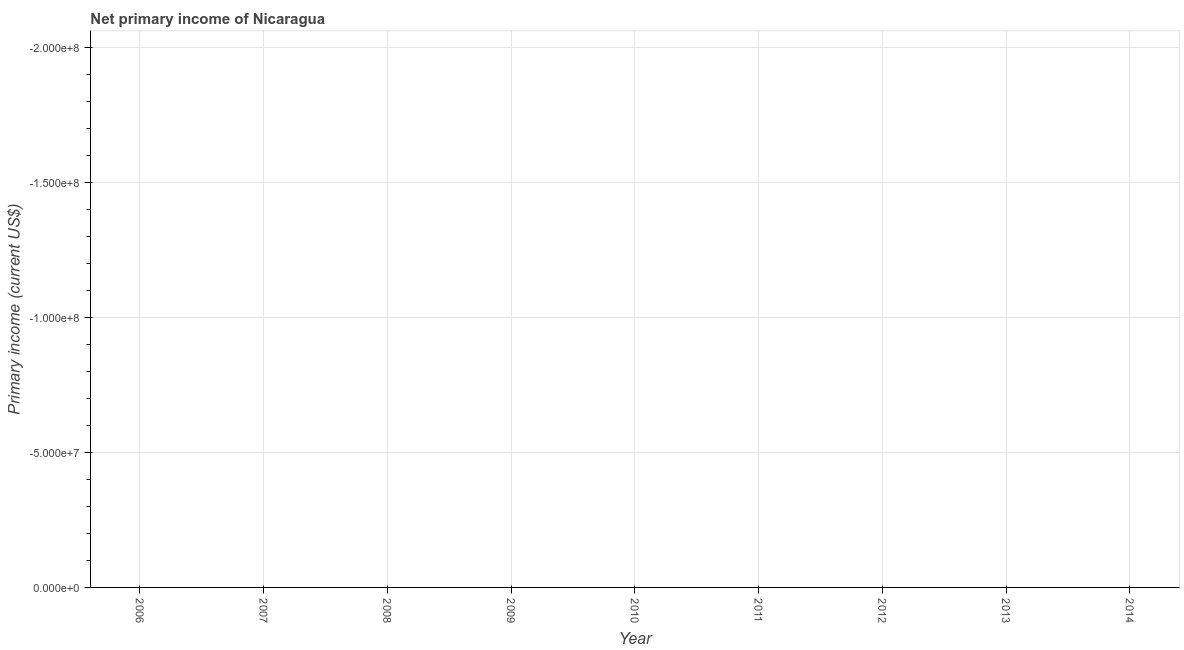What is the amount of primary income in 2009?
Give a very brief answer. 0. What is the sum of the amount of primary income?
Your response must be concise. 0. What is the average amount of primary income per year?
Ensure brevity in your answer.  0. In how many years, is the amount of primary income greater than -20000000 US$?
Provide a succinct answer. 0. In how many years, is the amount of primary income greater than the average amount of primary income taken over all years?
Offer a terse response. 0. How many years are there in the graph?
Your answer should be compact. 9. What is the difference between two consecutive major ticks on the Y-axis?
Make the answer very short. 5.00e+07. Does the graph contain any zero values?
Offer a very short reply. Yes. What is the title of the graph?
Give a very brief answer. Net primary income of Nicaragua. What is the label or title of the Y-axis?
Provide a succinct answer. Primary income (current US$). What is the Primary income (current US$) in 2006?
Offer a very short reply. 0. What is the Primary income (current US$) in 2008?
Offer a very short reply. 0. What is the Primary income (current US$) of 2010?
Give a very brief answer. 0. What is the Primary income (current US$) of 2012?
Offer a terse response. 0. What is the Primary income (current US$) in 2013?
Your answer should be very brief. 0. What is the Primary income (current US$) of 2014?
Your answer should be compact. 0. 